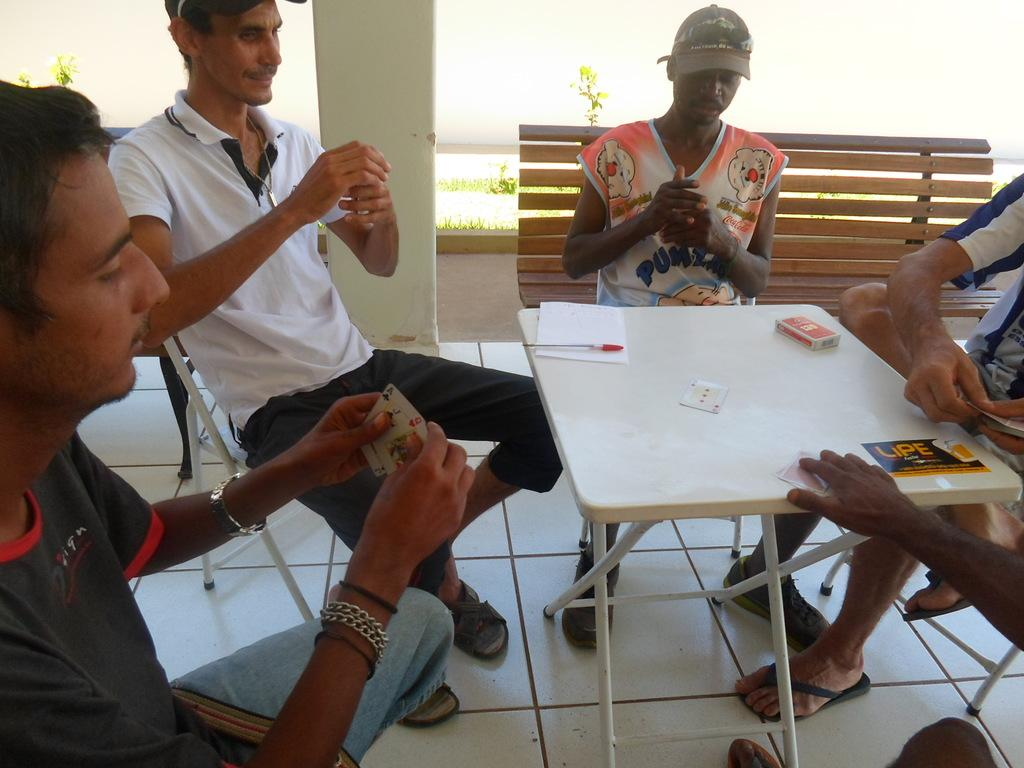What piece of furniture is present in the image? There is a table in the image. Where is the table located in the image? The table is on the right side of the image. What are the people around the table doing? The people are playing a game. Is there a volcano erupting in the background of the image? No, there is no volcano present in the image. 